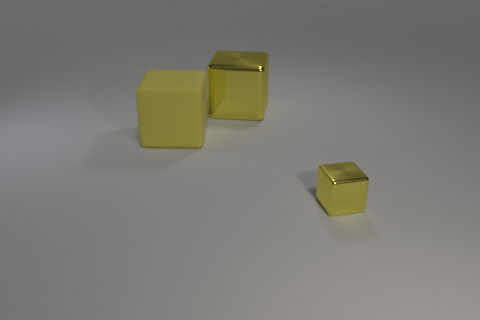What is the background like in the image? The background of the image is quite minimalistic, featuring a smooth, matte surface that seems to slope upwards at a shallow angle. It has a neutral color that could be described as a muted white or light gray, enhancing the visibility of the yellow cubes. 